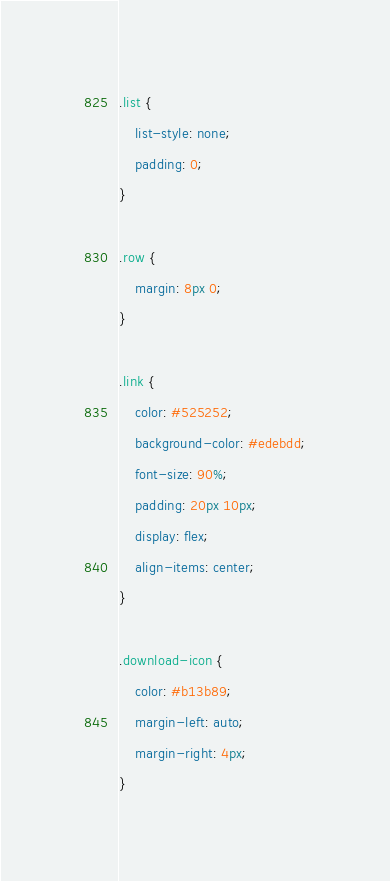<code> <loc_0><loc_0><loc_500><loc_500><_CSS_>.list {
    list-style: none;
    padding: 0;
}

.row {
    margin: 8px 0;
}

.link {
    color: #525252;
    background-color: #edebdd;
    font-size: 90%;
    padding: 20px 10px;
    display: flex;
    align-items: center;
}

.download-icon {
    color: #b13b89;
    margin-left: auto;
    margin-right: 4px;
}
</code> 